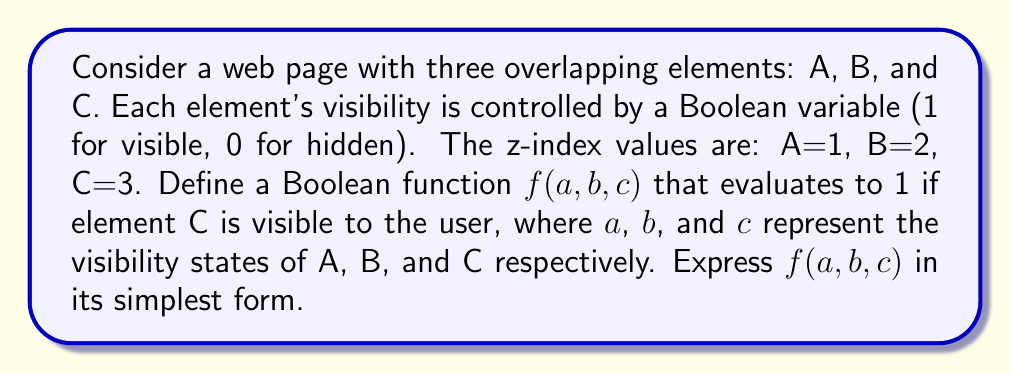Give your solution to this math problem. Let's approach this step-by-step:

1) For element C to be visible, two conditions must be met:
   a) C itself must be visible (c = 1)
   b) If any element with a higher z-index than C is visible, C will be hidden

2) In this case, C has the highest z-index, so condition (b) is always satisfied

3) Therefore, the visibility of C depends solely on its own visibility state

4) We can express this as a Boolean function:

   $$f(a,b,c) = c$$

5) This function is already in its simplest form, as it depends only on the variable c

6) To verify:
   - If c = 0, f(a,b,c) = 0 (C is hidden)
   - If c = 1, f(a,b,c) = 1 (C is visible)
   - The states of a and b do not affect the result

7) In terms of CSS stacking context, this demonstrates that an element with the highest z-index is only affected by its own visibility property, not by the visibility of elements below it in the stacking order
Answer: $f(a,b,c) = c$ 